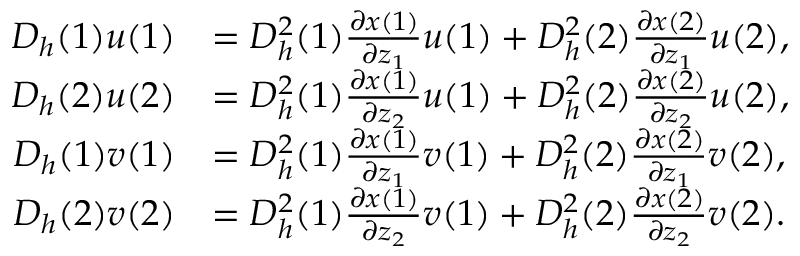<formula> <loc_0><loc_0><loc_500><loc_500>\begin{array} { r l } { D _ { h } ( 1 ) u ( 1 ) } & { = D _ { h } ^ { 2 } ( 1 ) \frac { \partial x ( 1 ) } { \partial z _ { 1 } } u ( 1 ) + D _ { h } ^ { 2 } ( 2 ) \frac { \partial x ( 2 ) } { \partial z _ { 1 } } u ( 2 ) , } \\ { D _ { h } ( 2 ) u ( 2 ) } & { = D _ { h } ^ { 2 } ( 1 ) \frac { \partial x ( 1 ) } { \partial z _ { 2 } } u ( 1 ) + D _ { h } ^ { 2 } ( 2 ) \frac { \partial x ( 2 ) } { \partial z _ { 2 } } u ( 2 ) , } \\ { D _ { h } ( 1 ) v ( 1 ) } & { = D _ { h } ^ { 2 } ( 1 ) \frac { \partial x ( 1 ) } { \partial z _ { 1 } } v ( 1 ) + D _ { h } ^ { 2 } ( 2 ) \frac { \partial x ( 2 ) } { \partial z _ { 1 } } v ( 2 ) , } \\ { D _ { h } ( 2 ) v ( 2 ) } & { = D _ { h } ^ { 2 } ( 1 ) \frac { \partial x ( 1 ) } { \partial z _ { 2 } } v ( 1 ) + D _ { h } ^ { 2 } ( 2 ) \frac { \partial x ( 2 ) } { \partial z _ { 2 } } v ( 2 ) . } \end{array}</formula> 